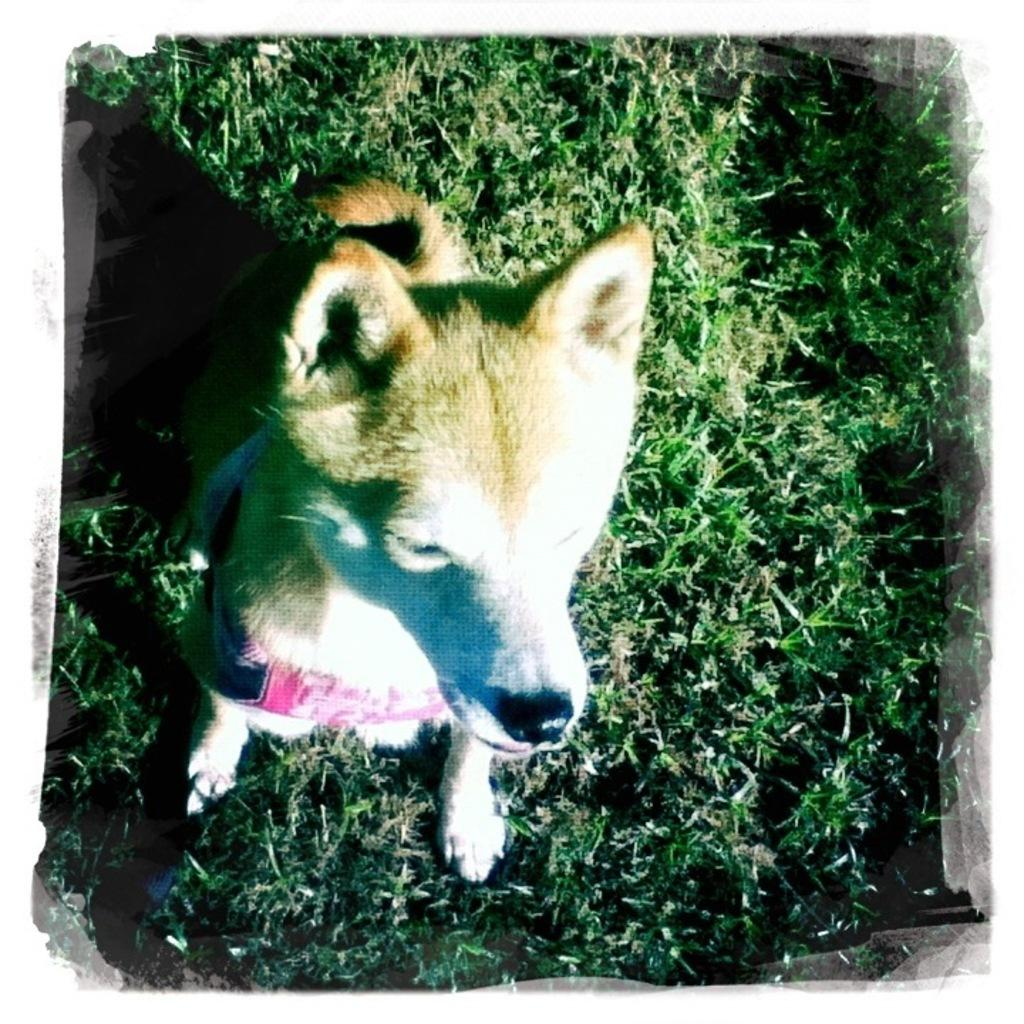What animal is present in the image? There is a dog in the image. Where is the dog located? The dog is on the grass. What type of window is visible in the image? There is no window present in the image; it features a dog on the grass. How does the dog express disgust in the image? The dog does not express disgust in the image, as there is no indication of its emotional state. 